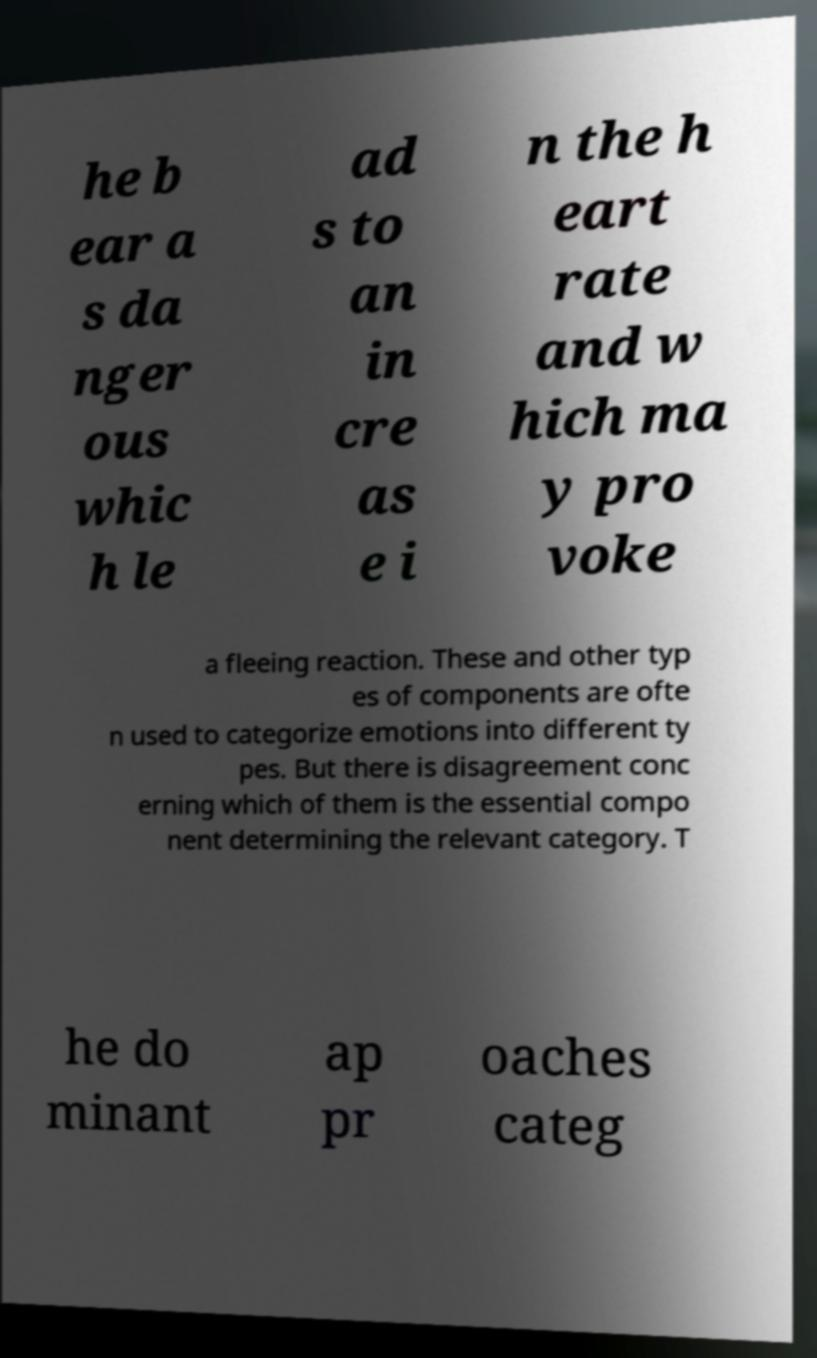I need the written content from this picture converted into text. Can you do that? he b ear a s da nger ous whic h le ad s to an in cre as e i n the h eart rate and w hich ma y pro voke a fleeing reaction. These and other typ es of components are ofte n used to categorize emotions into different ty pes. But there is disagreement conc erning which of them is the essential compo nent determining the relevant category. T he do minant ap pr oaches categ 